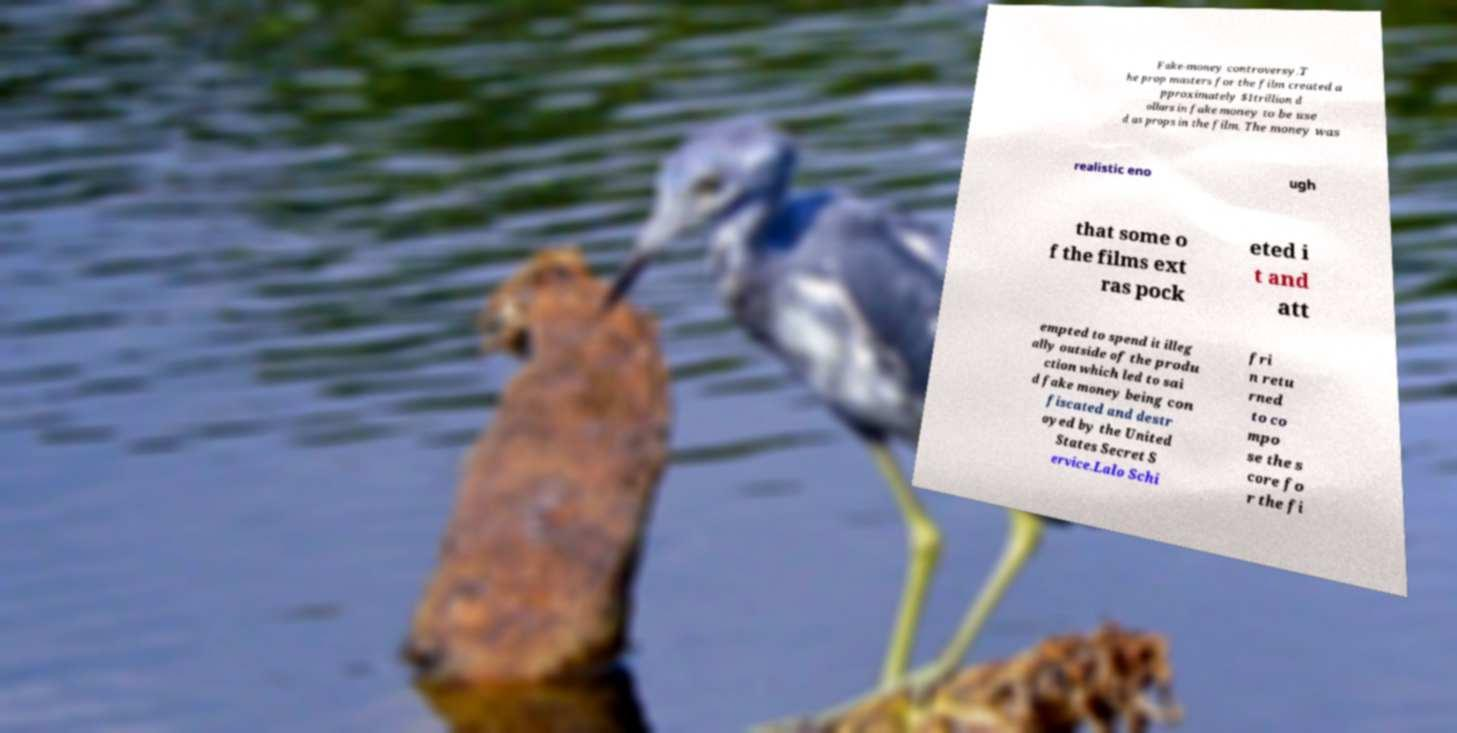Please identify and transcribe the text found in this image. Fake-money controversy.T he prop masters for the film created a pproximately $1trillion d ollars in fake money to be use d as props in the film. The money was realistic eno ugh that some o f the films ext ras pock eted i t and att empted to spend it illeg ally outside of the produ ction which led to sai d fake money being con fiscated and destr oyed by the United States Secret S ervice.Lalo Schi fri n retu rned to co mpo se the s core fo r the fi 